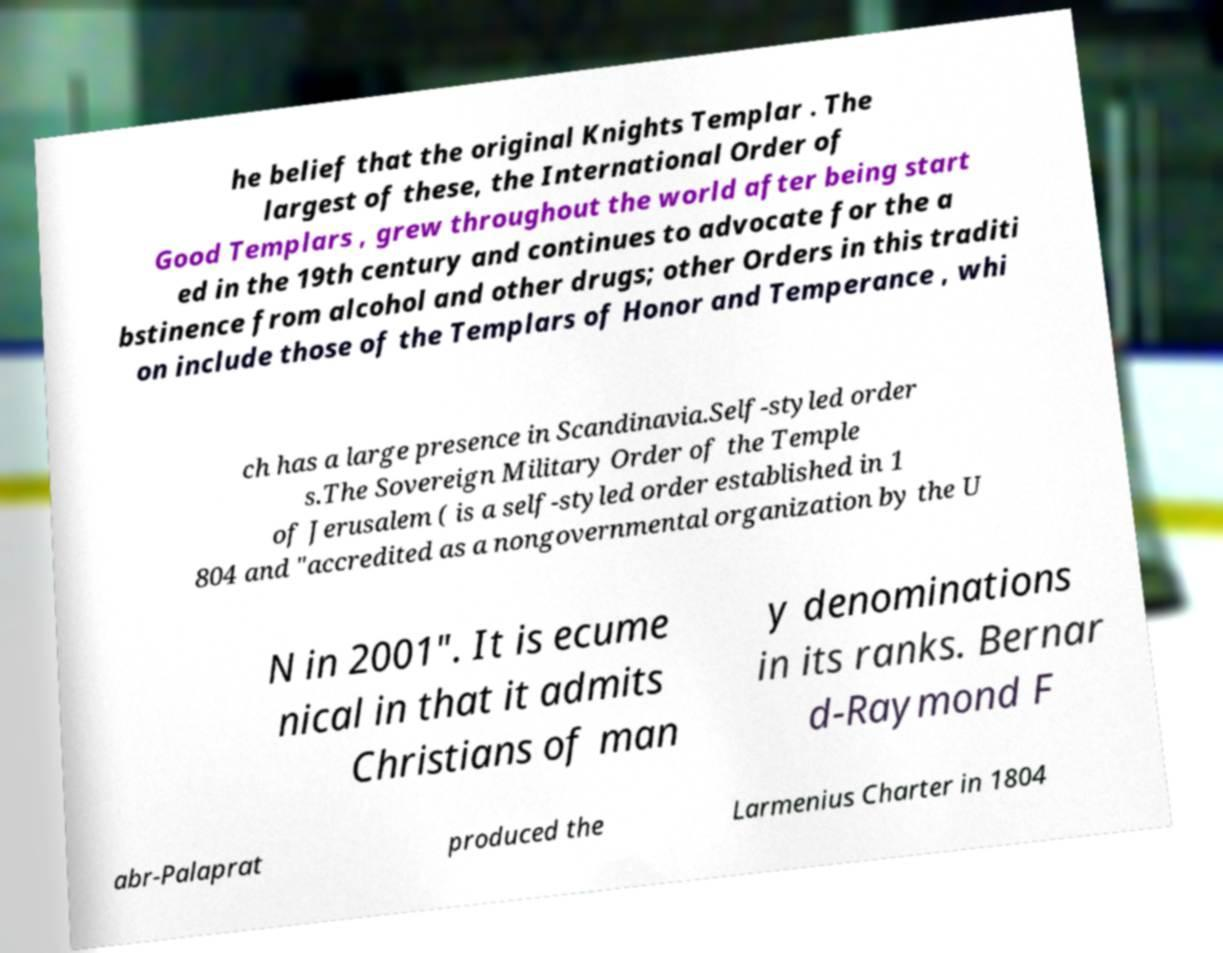Could you extract and type out the text from this image? he belief that the original Knights Templar . The largest of these, the International Order of Good Templars , grew throughout the world after being start ed in the 19th century and continues to advocate for the a bstinence from alcohol and other drugs; other Orders in this traditi on include those of the Templars of Honor and Temperance , whi ch has a large presence in Scandinavia.Self-styled order s.The Sovereign Military Order of the Temple of Jerusalem ( is a self-styled order established in 1 804 and "accredited as a nongovernmental organization by the U N in 2001". It is ecume nical in that it admits Christians of man y denominations in its ranks. Bernar d-Raymond F abr-Palaprat produced the Larmenius Charter in 1804 